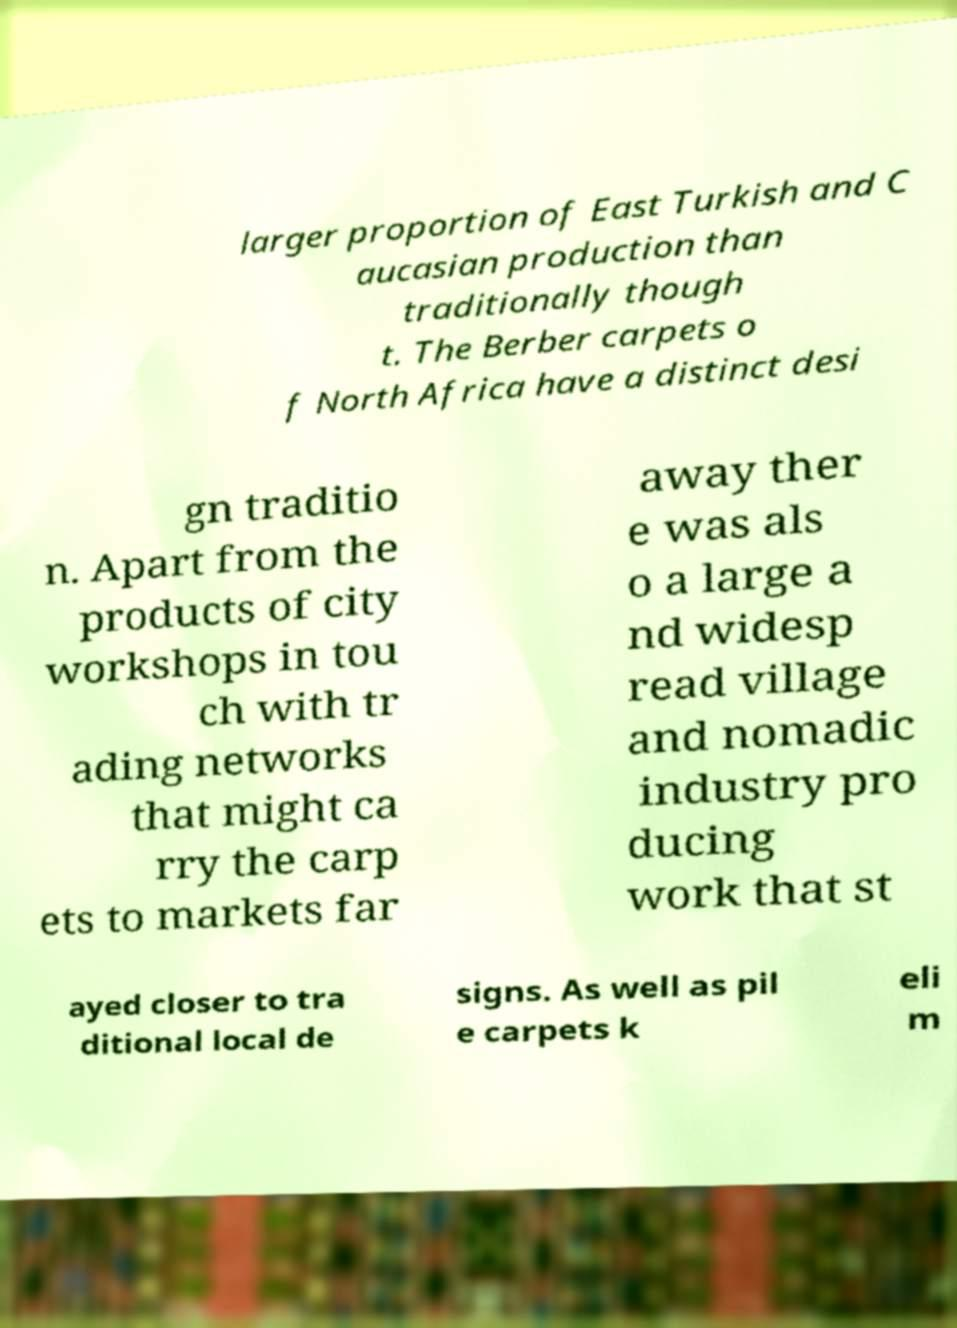For documentation purposes, I need the text within this image transcribed. Could you provide that? larger proportion of East Turkish and C aucasian production than traditionally though t. The Berber carpets o f North Africa have a distinct desi gn traditio n. Apart from the products of city workshops in tou ch with tr ading networks that might ca rry the carp ets to markets far away ther e was als o a large a nd widesp read village and nomadic industry pro ducing work that st ayed closer to tra ditional local de signs. As well as pil e carpets k eli m 